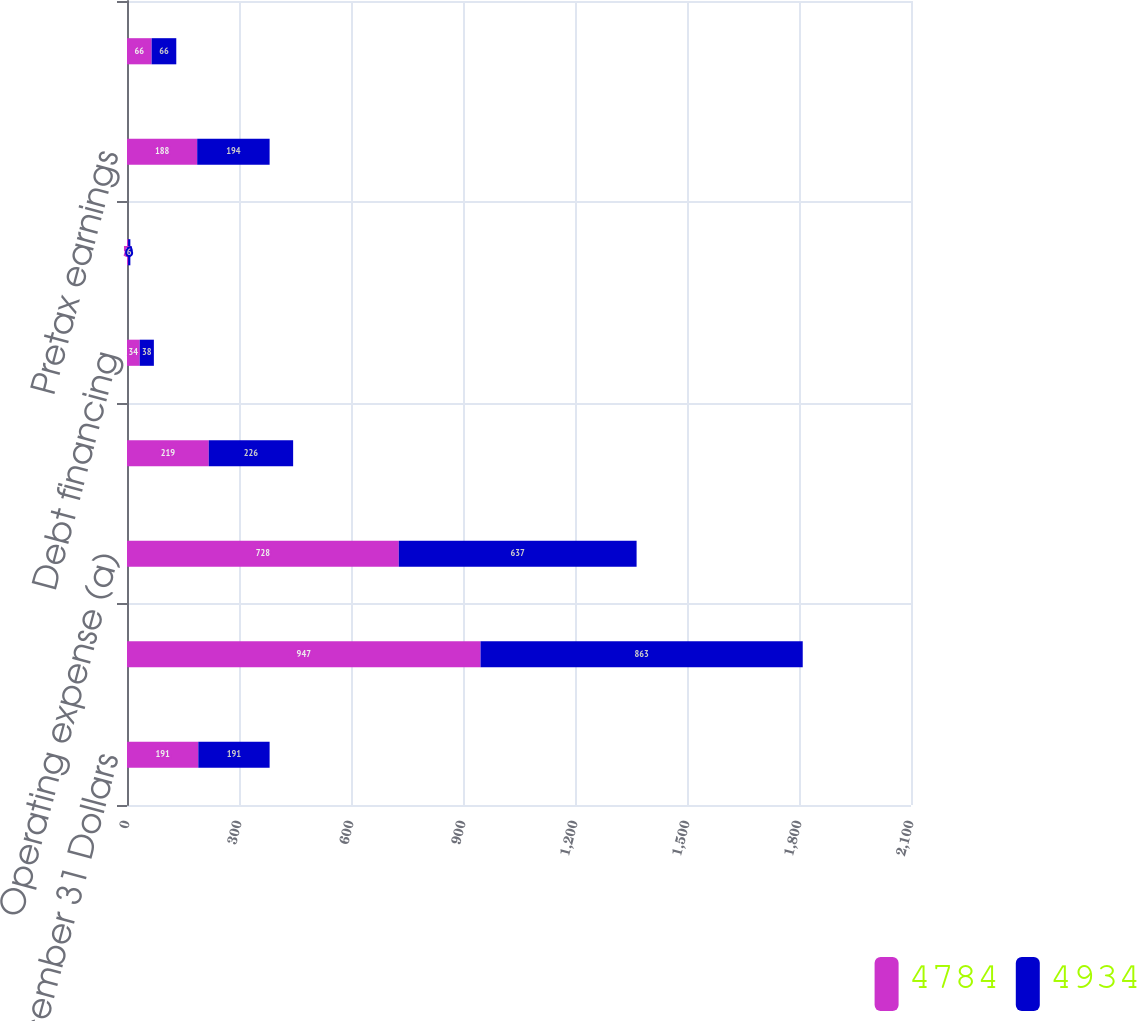<chart> <loc_0><loc_0><loc_500><loc_500><stacked_bar_chart><ecel><fcel>Year ended December 31 Dollars<fcel>Servicing revenue (a)<fcel>Operating expense (a)<fcel>Operating income<fcel>Debt financing<fcel>Nonoperating income (b)<fcel>Pretax earnings<fcel>Income taxes<nl><fcel>4784<fcel>191<fcel>947<fcel>728<fcel>219<fcel>34<fcel>3<fcel>188<fcel>66<nl><fcel>4934<fcel>191<fcel>863<fcel>637<fcel>226<fcel>38<fcel>6<fcel>194<fcel>66<nl></chart> 